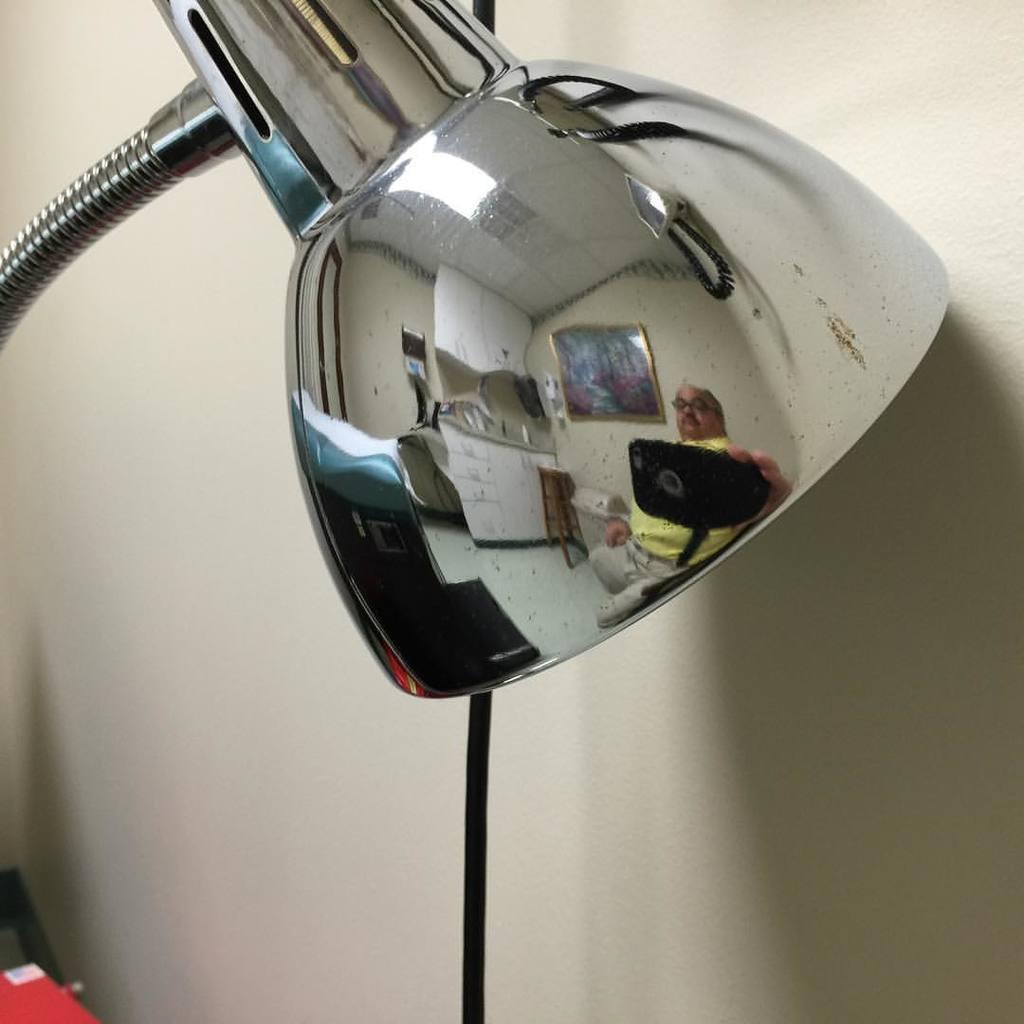Can you describe this image briefly? In this image we can see an object looks like a table lamp and on the lamp we can see the reflection of a person holding a cellphone, a table and a picture frame to the wall and there is a wire near the lamp. 